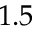Convert formula to latex. <formula><loc_0><loc_0><loc_500><loc_500>1 . 5</formula> 